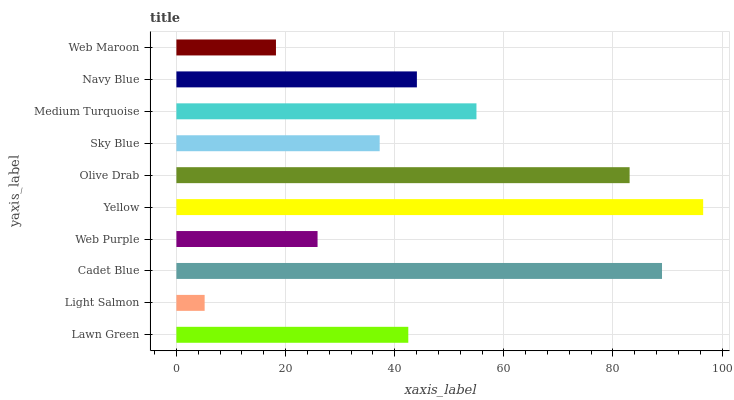Is Light Salmon the minimum?
Answer yes or no. Yes. Is Yellow the maximum?
Answer yes or no. Yes. Is Cadet Blue the minimum?
Answer yes or no. No. Is Cadet Blue the maximum?
Answer yes or no. No. Is Cadet Blue greater than Light Salmon?
Answer yes or no. Yes. Is Light Salmon less than Cadet Blue?
Answer yes or no. Yes. Is Light Salmon greater than Cadet Blue?
Answer yes or no. No. Is Cadet Blue less than Light Salmon?
Answer yes or no. No. Is Navy Blue the high median?
Answer yes or no. Yes. Is Lawn Green the low median?
Answer yes or no. Yes. Is Sky Blue the high median?
Answer yes or no. No. Is Navy Blue the low median?
Answer yes or no. No. 